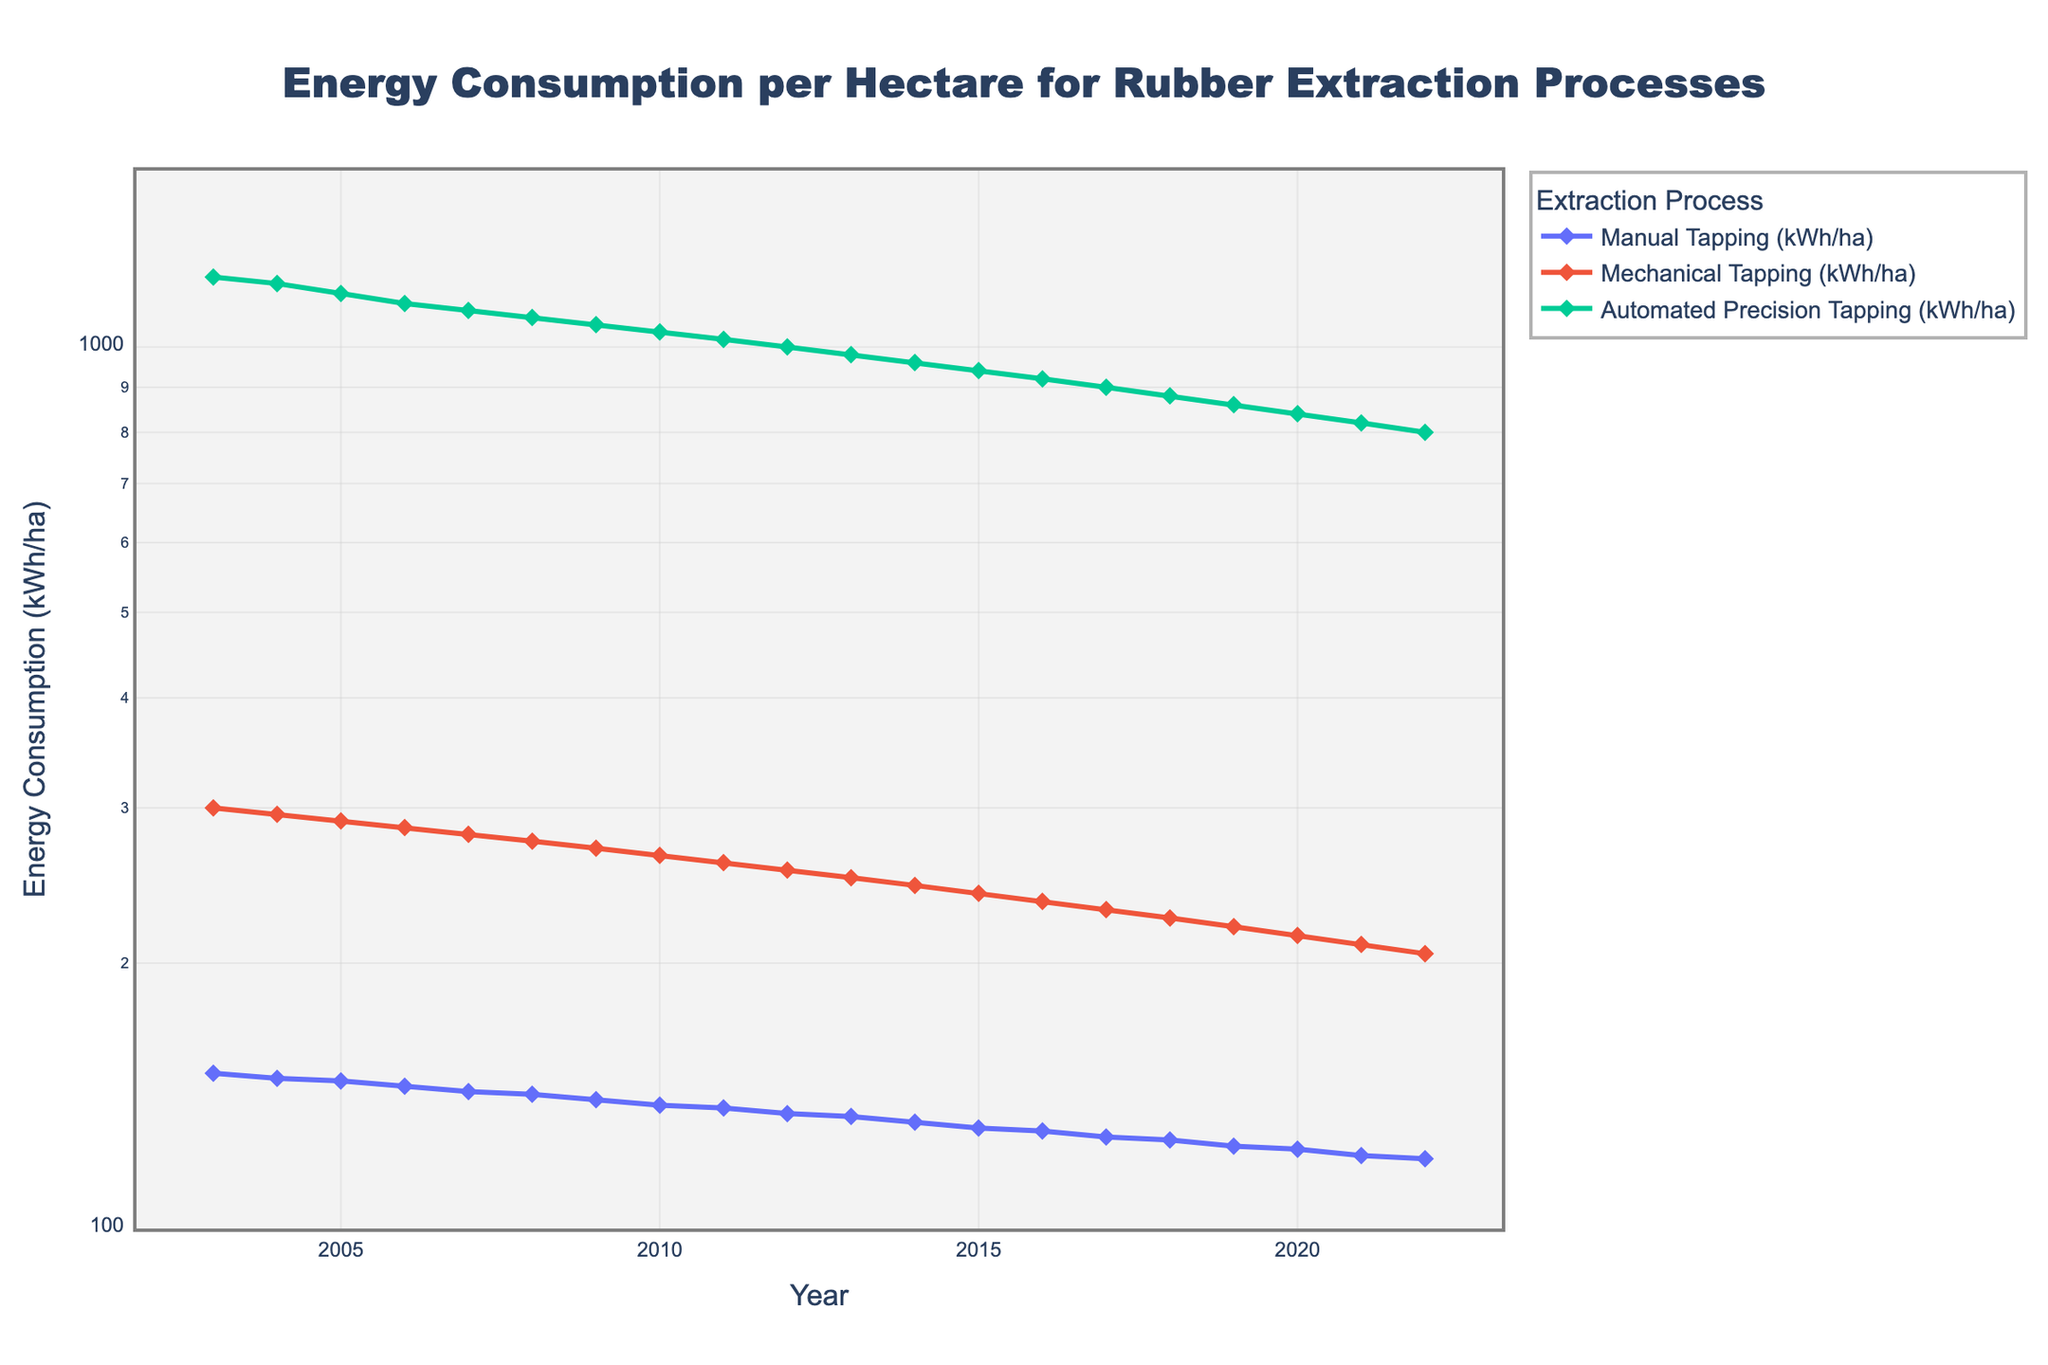what's the title of the figure? The title is typically found at the top of the figure, summarizing its purpose. In this case, it is "Energy Consumption per Hectare for Rubber Extraction Processes."
Answer: Energy Consumption per Hectare for Rubber Extraction Processes what's the y-axis range in the figure? The y-axis is shown in a logarithmic scale, spanning from 100 to 1500 (covering a range from log10(100)=2 to log10(1500) approximately).
Answer: 100 to 1500 which extraction process has the highest energy consumption in 2006? By looking at the plotted lines for the year 2006, one can see the topmost line on the log scale axis for the year 2006, and it's Automated Precision Tapping.
Answer: Automated Precision Tapping how many processes are compared in the figure? The legend of the figure lists the different processes compared: Manual Tapping, Mechanical Tapping, and Automated Precision Tapping.
Answer: 3 what is the trend for the Mechanical Tapping process over the years? Observing the Mechanical Tapping data points from 2003 to 2022 shows a consistent decrease in energy consumption over time.
Answer: Decreasing which year shows the largest difference in energy consumption between Manual Tapping and Automated Precision Tapping? Identify the year where the vertical gap between the Manual Tapping and the Automated Precision Tapping lines is the largest. In this case, the gap is generally widest in the earlier years like 2003.
Answer: 2003 by how much did the energy consumption for Automated Precision Tapping decrease from 2003 to 2022? Subtract the energy consumption in 2022 (800 kWh/ha) from that in 2003 (1200 kWh/ha). This calculates to a decrease of 400 kWh/ha.
Answer: 400 kWh/ha how does the energy consumption trend for Manual Tapping compare to Mechanical Tapping? By viewing both trends from 2003 to 2022, both processes show a decrease, but the rate of decrease for Manual Tapping appears slightly more rapid compared to Mechanical Tapping.
Answer: More rapid decrease for Manual Tapping what is the approximate energy consumption for Mechanical Tapping in 2010? Locate the data point (or trace) for Mechanical Tapping at the year 2010 and read the y-axis value, which is approximately 265 kWh/ha.
Answer: 265 kWh/ha which extraction process closes the energy consumption gap most rapidly over the observed years? By observing the slopes of the lines, Manual Tapping's steeper decline (especially compared to others) indicates it is closing its gap to the other processes most rapidly.
Answer: Manual Tapping 